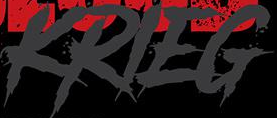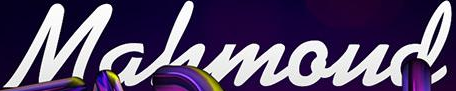What words can you see in these images in sequence, separated by a semicolon? KRIEG; Mahmoud 